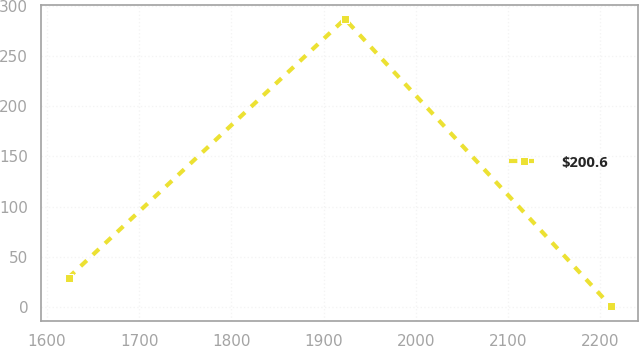Convert chart. <chart><loc_0><loc_0><loc_500><loc_500><line_chart><ecel><fcel>$200.6<nl><fcel>1623.53<fcel>29.4<nl><fcel>1923.08<fcel>286.66<nl><fcel>2211.51<fcel>0.82<nl></chart> 